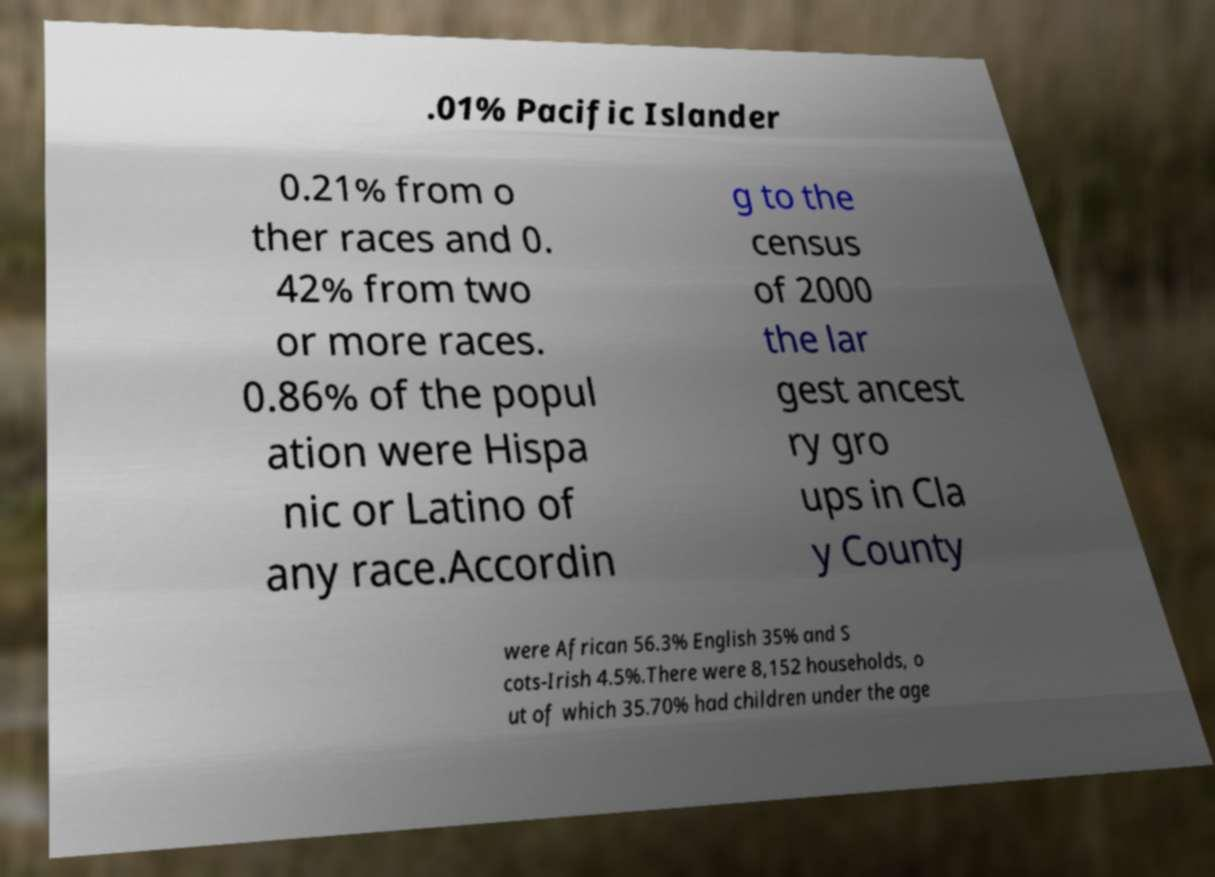Can you read and provide the text displayed in the image?This photo seems to have some interesting text. Can you extract and type it out for me? .01% Pacific Islander 0.21% from o ther races and 0. 42% from two or more races. 0.86% of the popul ation were Hispa nic or Latino of any race.Accordin g to the census of 2000 the lar gest ancest ry gro ups in Cla y County were African 56.3% English 35% and S cots-Irish 4.5%.There were 8,152 households, o ut of which 35.70% had children under the age 